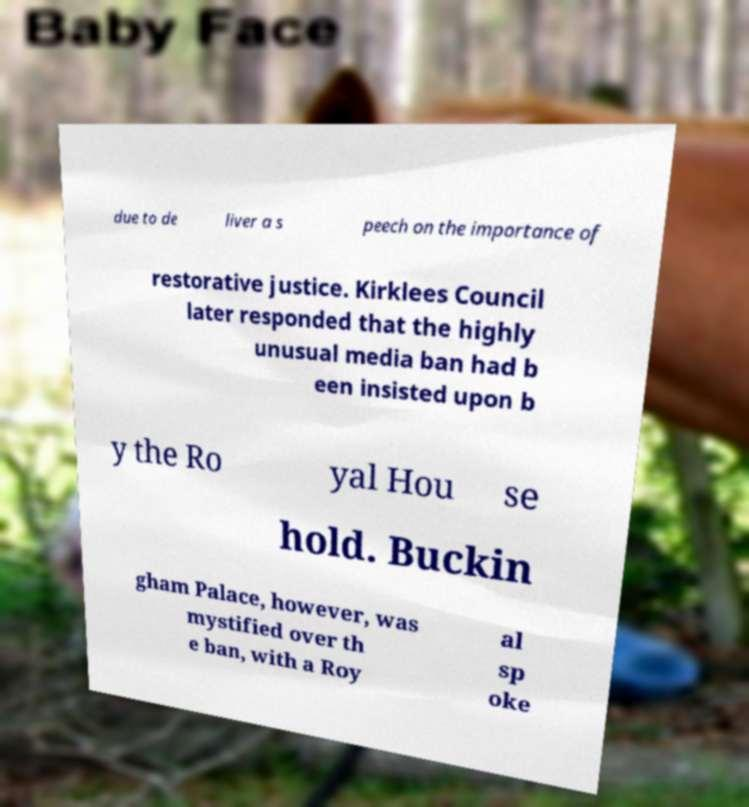Can you accurately transcribe the text from the provided image for me? due to de liver a s peech on the importance of restorative justice. Kirklees Council later responded that the highly unusual media ban had b een insisted upon b y the Ro yal Hou se hold. Buckin gham Palace, however, was mystified over th e ban, with a Roy al sp oke 